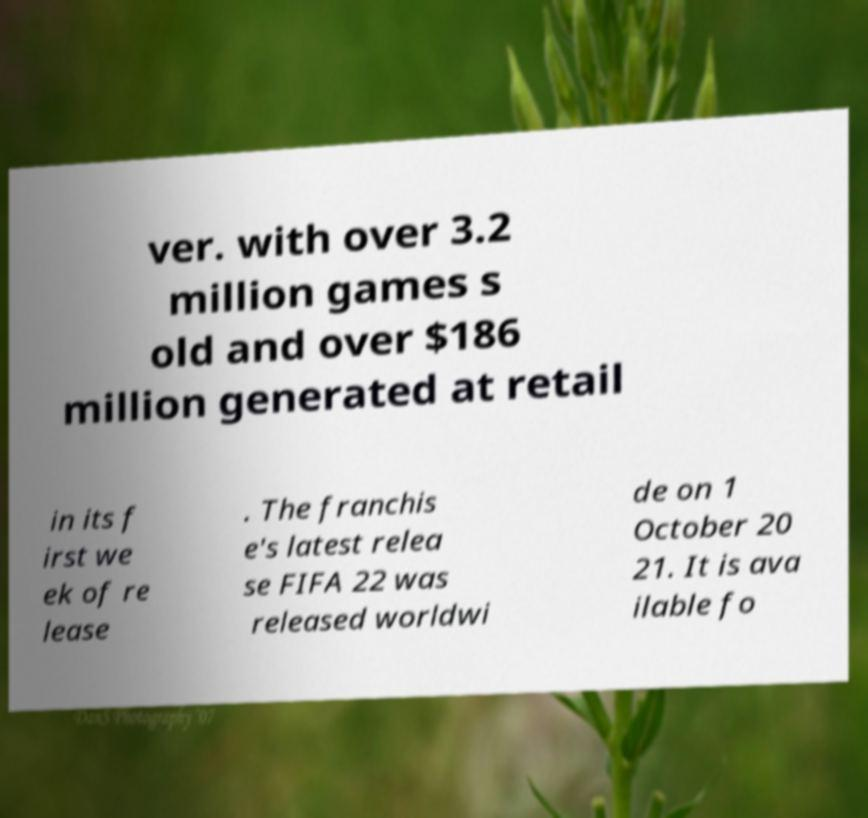There's text embedded in this image that I need extracted. Can you transcribe it verbatim? ver. with over 3.2 million games s old and over $186 million generated at retail in its f irst we ek of re lease . The franchis e's latest relea se FIFA 22 was released worldwi de on 1 October 20 21. It is ava ilable fo 